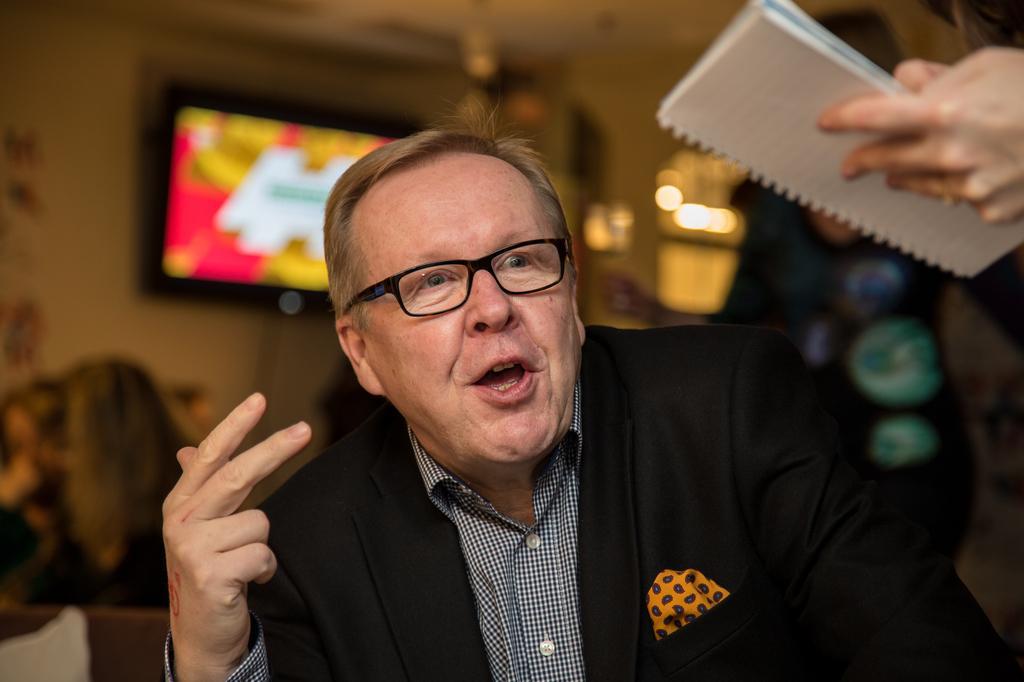In one or two sentences, can you explain what this image depicts? In the picture there is a man,he is wearing a black blazer and spectacles and a checkered shirt. He is speaking something and in front of the man there is some other person who is standing and writing something on the book and the background is blurry. 